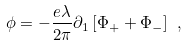Convert formula to latex. <formula><loc_0><loc_0><loc_500><loc_500>\phi = - \frac { e \lambda } { 2 \pi } \partial _ { 1 } \left [ \Phi _ { + } + \Phi _ { - } \right ] \ ,</formula> 